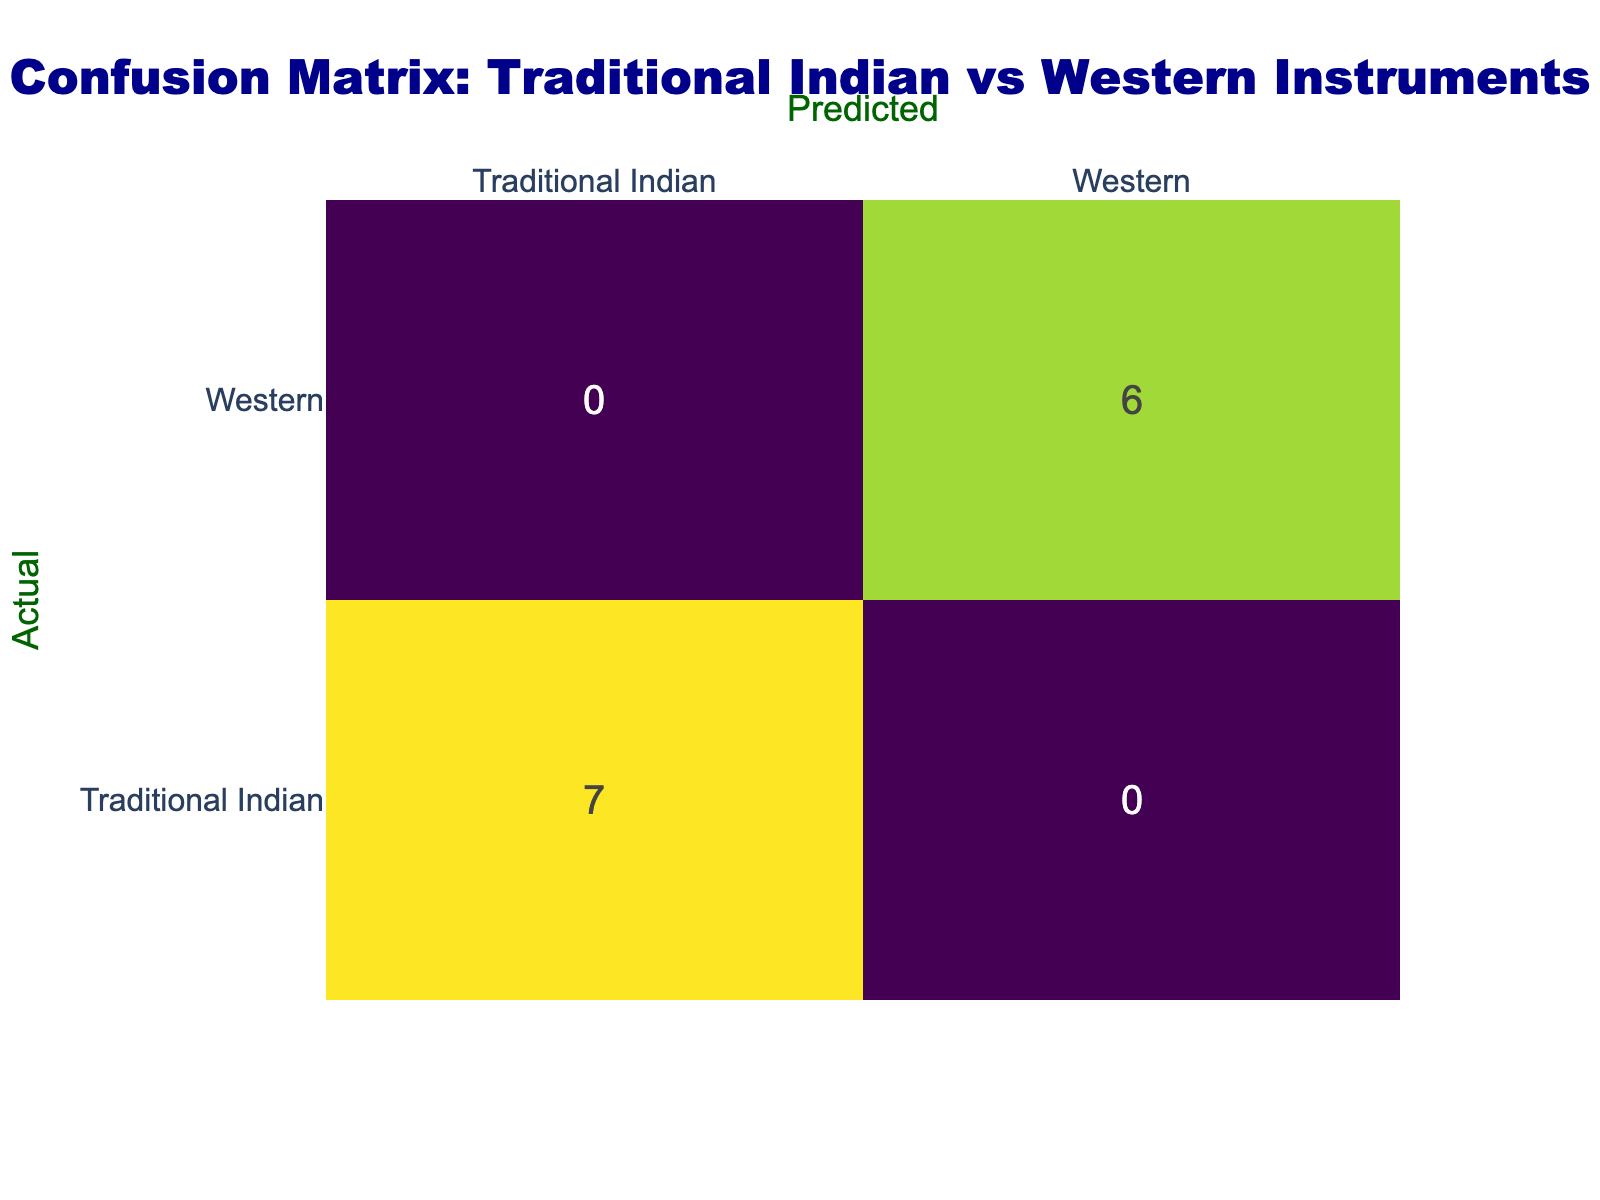What is the total count of Traditional Indian instruments? From the table, we can identify that the Traditional Indian instruments listed include Sitar, Tabla, Harmonium, Bansuri, Santoor, Pakhawaj, and Sarangi. Counting these, we have 7 instruments.
Answer: 7 How many Western instruments are represented in the table? The Western instruments identified in the table are Cello, Violin, Guitar, Double Bass, Flute, and Clarinet. By counting these, we find there are 6 instruments.
Answer: 6 Is the Cello classified as a Traditional Indian instrument? Referring to the table, Cello is listed under the Western category. Thus, it is not a Traditional Indian instrument.
Answer: No Which category has more instruments listed, Traditional Indian or Western? Counting the instruments, there are 7 Traditional Indian instruments and 6 Western instruments. Since 7 is greater than 6, Traditional Indian instruments are more numerous.
Answer: Traditional Indian What is the difference in the number of instruments between the two categories? We have 7 Traditional Indian instruments and 6 Western instruments. The difference can be calculated as 7 - 6 = 1.
Answer: 1 If we take the ratio of Traditional Indian instruments to Western instruments, what is it? The number of Traditional Indian instruments is 7 and Western instruments is 6. Thus, the ratio is 7:6, which can be expressed as 7/6.
Answer: 7:6 Are there more string instruments than wind instruments in the list? From the table, string instruments include Sitar, Cello, Guitar, Santoor, and Violin (5 in total), while wind instruments include Bansuri, Flute, and Clarinet (3 in total). Comparing the numbers, 5 is greater than 3.
Answer: Yes How many more Traditional Indian instruments are there compared to the most popular Western instrument (assuming popularity means frequency in this context)? The most frequent Western instruments from this list is 1 since each Western instrument is only counted once. Traditional Indian instruments total 7. Therefore, the difference is 7 - 1 = 6.
Answer: 6 What percentage of the total instruments are Traditional Indian instruments? The total number of instruments is 7 (Traditional Indian) + 6 (Western) = 13. The number of Traditional Indian instruments is 7. To calculate the percentage: (7/13) * 100 = approximately 53.85%.
Answer: 53.85% 